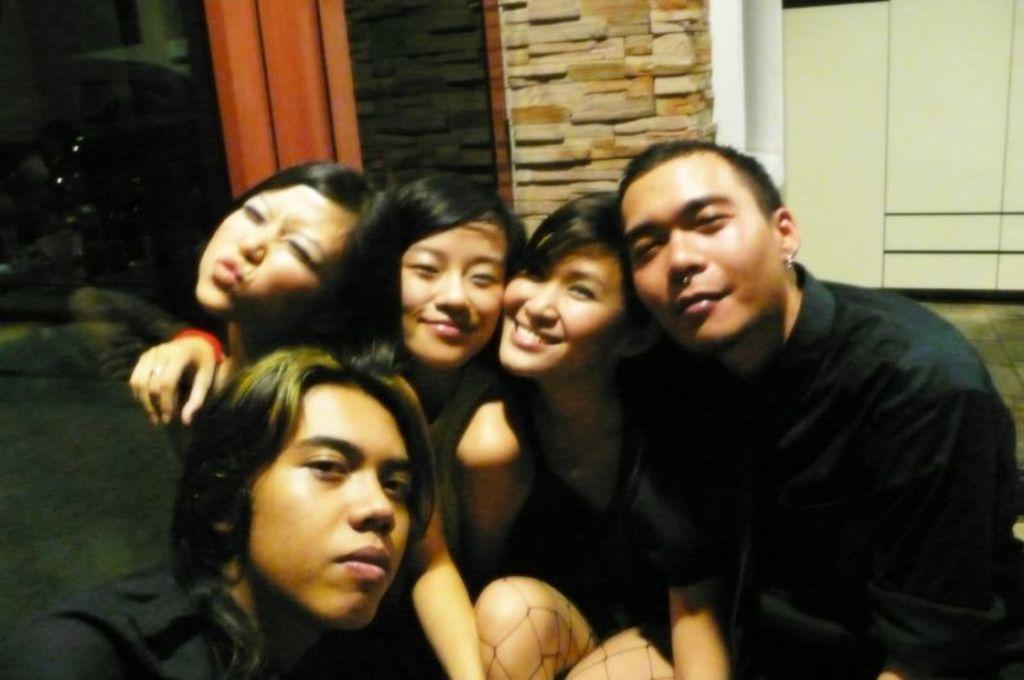How would you summarize this image in a sentence or two? In this image we can see a group of people. In the background we can see walls and floor. 